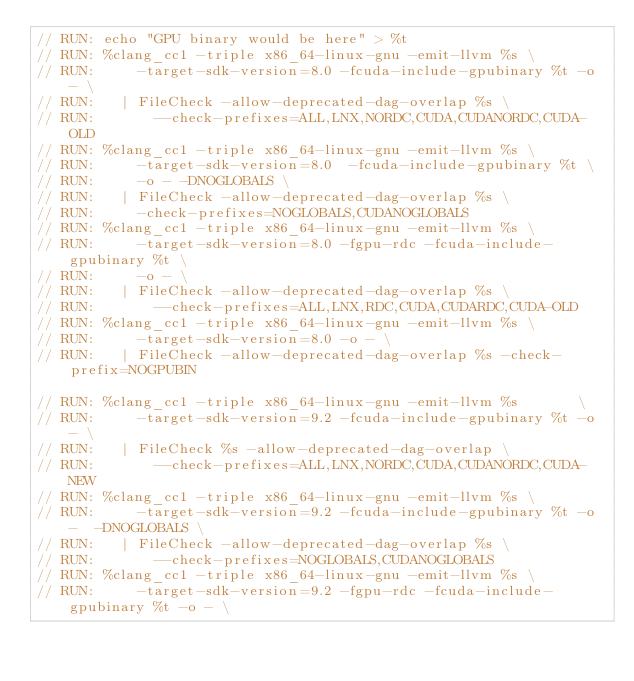Convert code to text. <code><loc_0><loc_0><loc_500><loc_500><_Cuda_>// RUN: echo "GPU binary would be here" > %t
// RUN: %clang_cc1 -triple x86_64-linux-gnu -emit-llvm %s \
// RUN:     -target-sdk-version=8.0 -fcuda-include-gpubinary %t -o - \
// RUN:   | FileCheck -allow-deprecated-dag-overlap %s \
// RUN:       --check-prefixes=ALL,LNX,NORDC,CUDA,CUDANORDC,CUDA-OLD
// RUN: %clang_cc1 -triple x86_64-linux-gnu -emit-llvm %s \
// RUN:     -target-sdk-version=8.0  -fcuda-include-gpubinary %t \
// RUN:     -o - -DNOGLOBALS \
// RUN:   | FileCheck -allow-deprecated-dag-overlap %s \
// RUN:     -check-prefixes=NOGLOBALS,CUDANOGLOBALS
// RUN: %clang_cc1 -triple x86_64-linux-gnu -emit-llvm %s \
// RUN:     -target-sdk-version=8.0 -fgpu-rdc -fcuda-include-gpubinary %t \
// RUN:     -o - \
// RUN:   | FileCheck -allow-deprecated-dag-overlap %s \
// RUN:       --check-prefixes=ALL,LNX,RDC,CUDA,CUDARDC,CUDA-OLD
// RUN: %clang_cc1 -triple x86_64-linux-gnu -emit-llvm %s \
// RUN:     -target-sdk-version=8.0 -o - \
// RUN:   | FileCheck -allow-deprecated-dag-overlap %s -check-prefix=NOGPUBIN

// RUN: %clang_cc1 -triple x86_64-linux-gnu -emit-llvm %s       \
// RUN:     -target-sdk-version=9.2 -fcuda-include-gpubinary %t -o - \
// RUN:   | FileCheck %s -allow-deprecated-dag-overlap \
// RUN:       --check-prefixes=ALL,LNX,NORDC,CUDA,CUDANORDC,CUDA-NEW
// RUN: %clang_cc1 -triple x86_64-linux-gnu -emit-llvm %s \
// RUN:     -target-sdk-version=9.2 -fcuda-include-gpubinary %t -o -  -DNOGLOBALS \
// RUN:   | FileCheck -allow-deprecated-dag-overlap %s \
// RUN:       --check-prefixes=NOGLOBALS,CUDANOGLOBALS
// RUN: %clang_cc1 -triple x86_64-linux-gnu -emit-llvm %s \
// RUN:     -target-sdk-version=9.2 -fgpu-rdc -fcuda-include-gpubinary %t -o - \</code> 